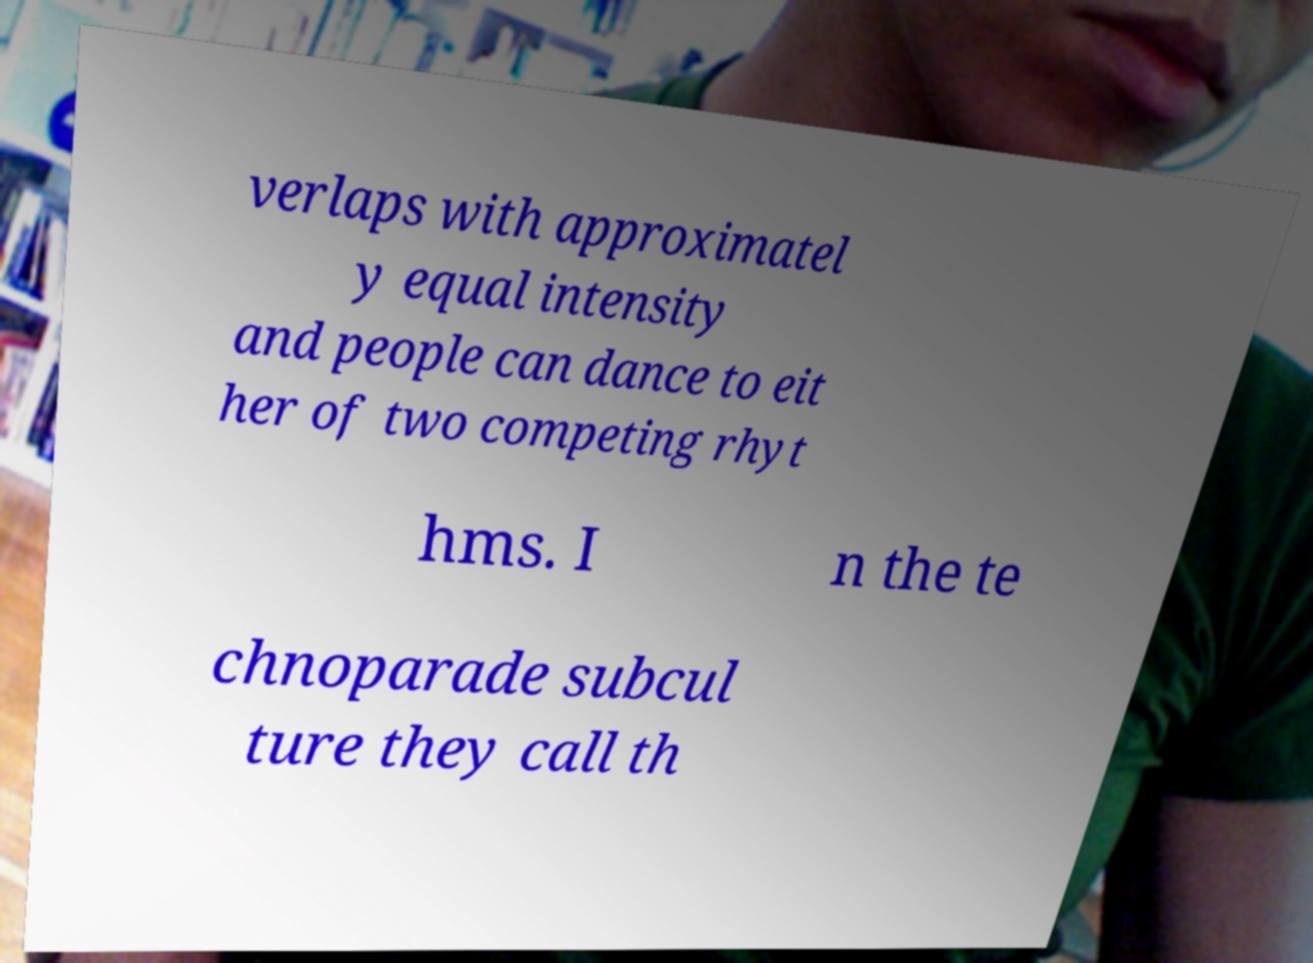I need the written content from this picture converted into text. Can you do that? verlaps with approximatel y equal intensity and people can dance to eit her of two competing rhyt hms. I n the te chnoparade subcul ture they call th 